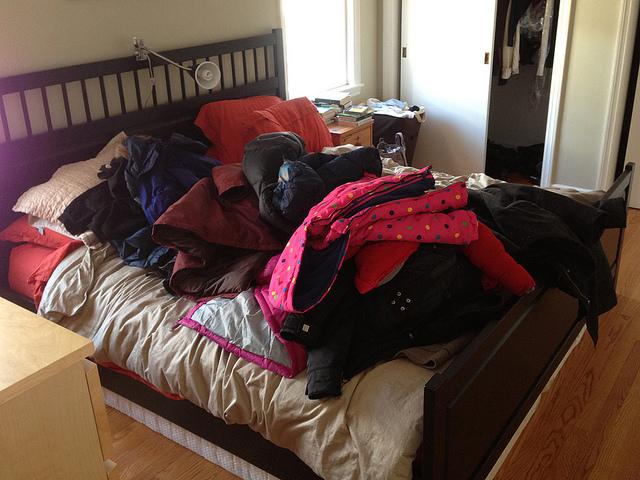Why are the coats piled up?
Be succinct. Cleaning. Is this bed in disarray?
Answer briefly. Yes. What is on the pink jacket?
Keep it brief. Dots. 